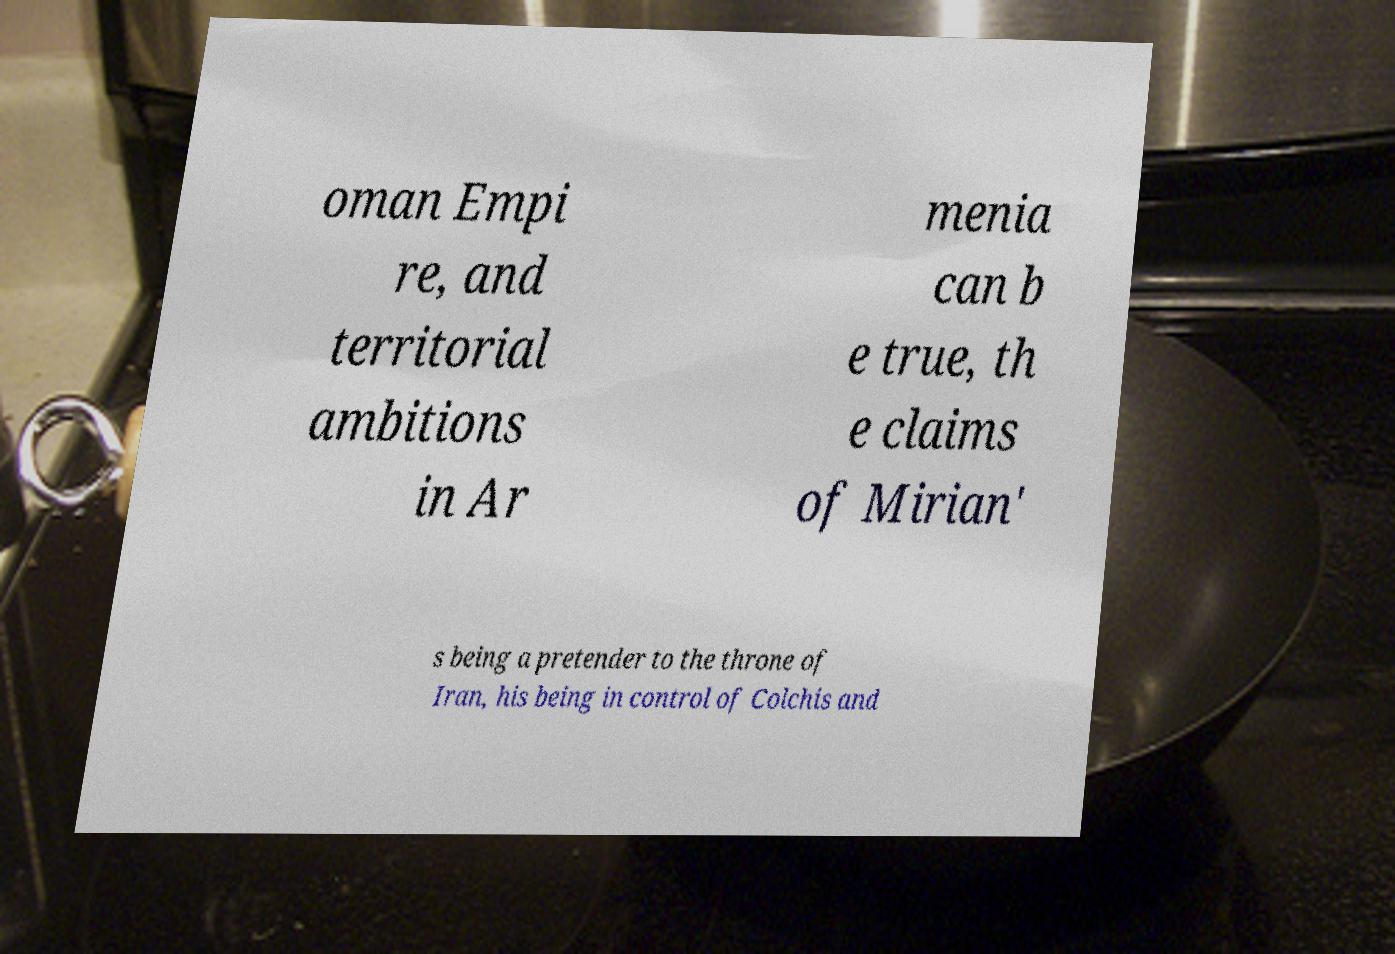There's text embedded in this image that I need extracted. Can you transcribe it verbatim? oman Empi re, and territorial ambitions in Ar menia can b e true, th e claims of Mirian' s being a pretender to the throne of Iran, his being in control of Colchis and 